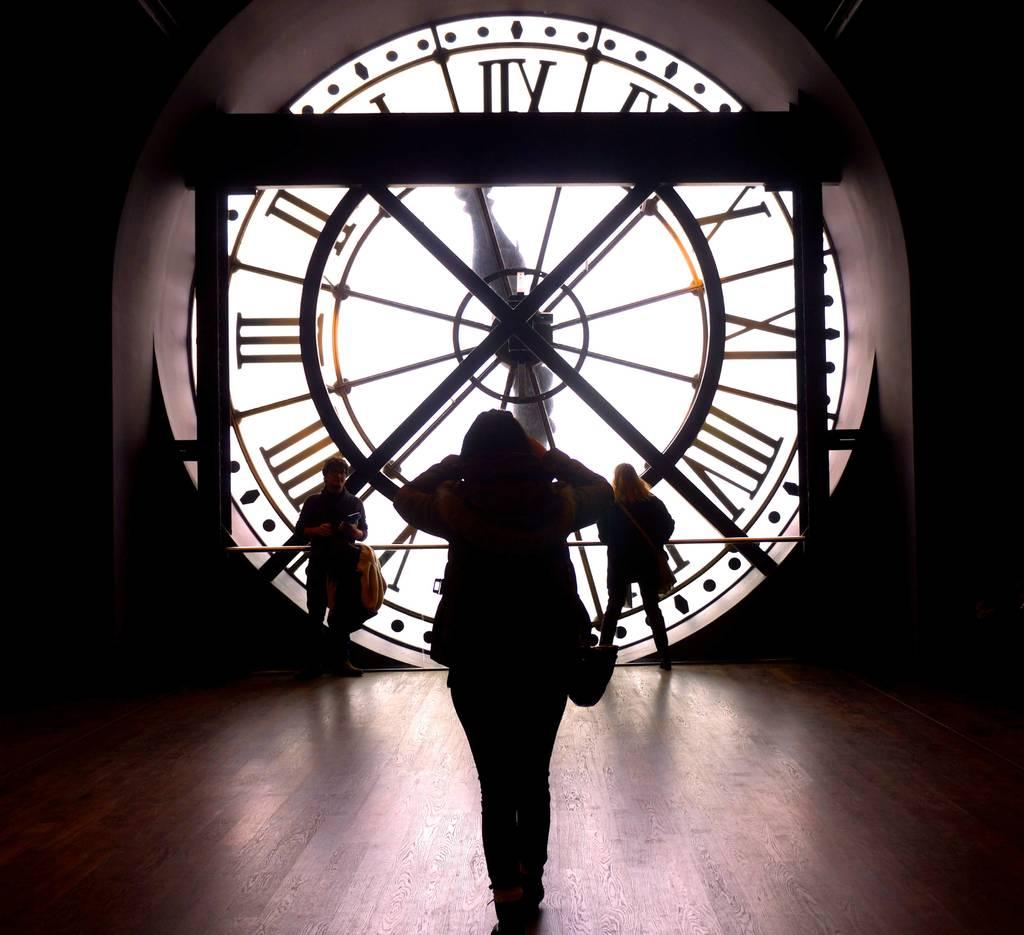How many people are in the image? There is a group of persons in the image. What are some of the people doing in the image? Some of the persons are walking, and some are carrying bags. What can be seen in the background of the image? There is a clock visible in the background of the image. Can you tell me how much income the cat in the image earns? There is no cat present in the image, so it is not possible to determine its income. 